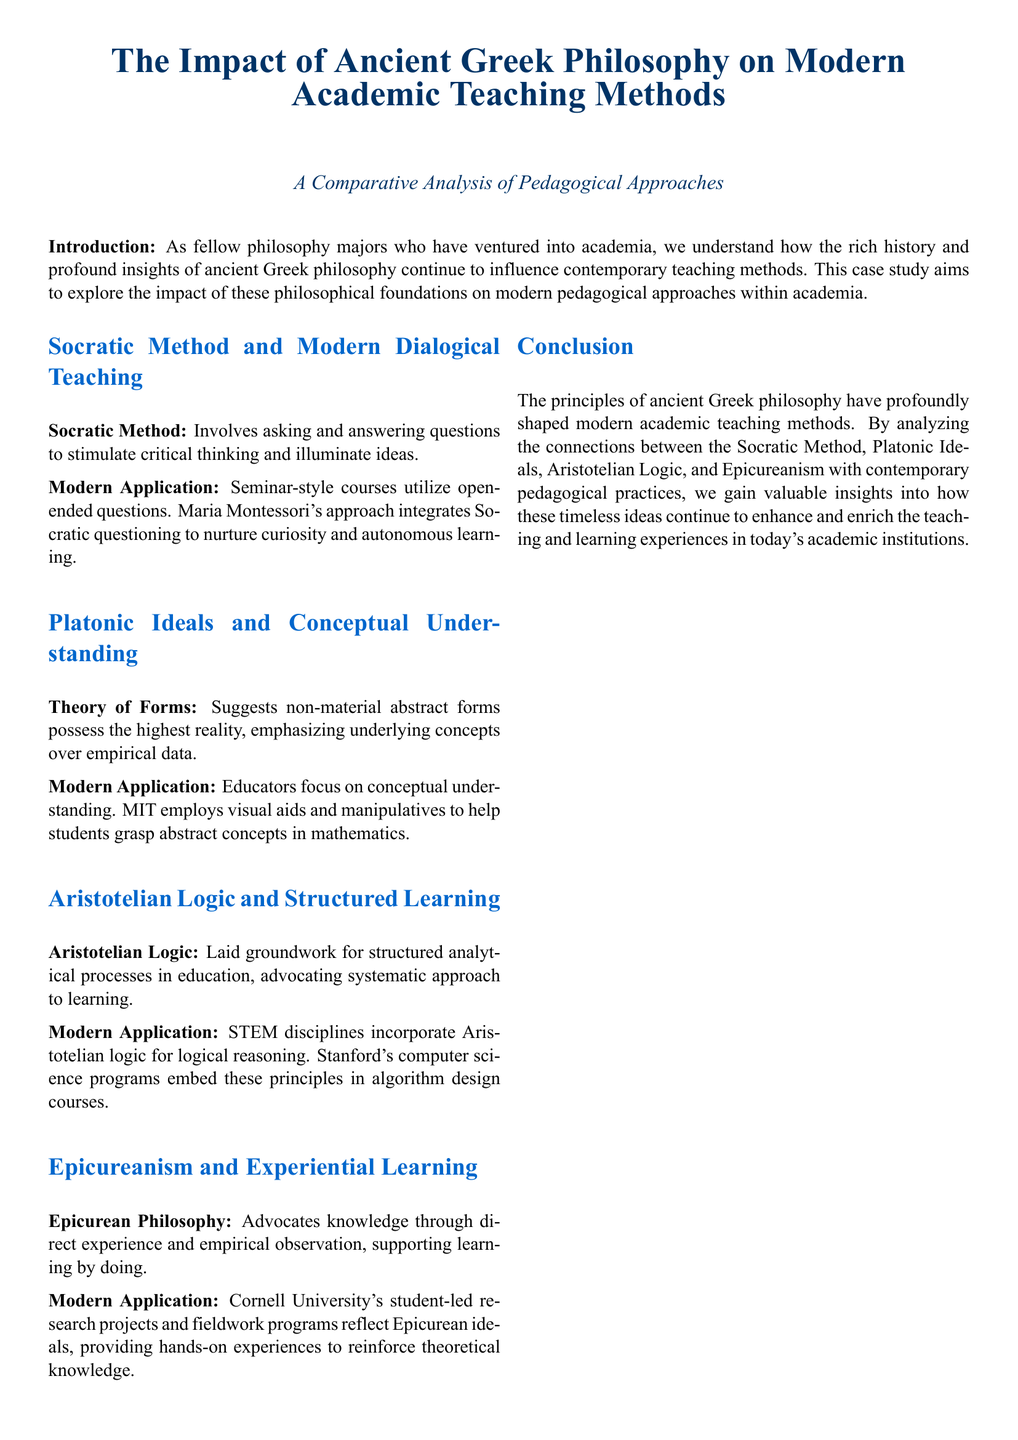What is the main focus of the case study? The case study focuses on the impact of ancient Greek philosophy on modern academic teaching methods.
Answer: The impact of ancient Greek philosophy on modern academic teaching methods Which philosophical method is linked to modern dialogical teaching? The case study mentions the Socratic Method as a historical approach influencing modern teaching.
Answer: Socratic Method What teaching method is associated with Maria Montessori? The document states that her approach integrates Socratic questioning as a key element.
Answer: Socratic questioning Which university is mentioned in relation to experiential learning? The case study references Cornell University in the context of hands-on learning experiences.
Answer: Cornell University What philosophical concept emphasizes knowledge through direct experience? The case study attributes the idea of knowledge through experience to Epicurean philosophy.
Answer: Epicureanism How does the document describe modern applications of Aristotelian logic? It highlights that STEM disciplines use Aristotelian logic in educational contexts.
Answer: STEM disciplines What does the Theory of Forms emphasize according to the document? The Theory of Forms is described as emphasizing non-material abstract forms over empirical data.
Answer: Non-material abstract forms What approach does MIT use to aid conceptual understanding? The document notes that MIT employs visual aids and manipulatives for teaching.
Answer: Visual aids and manipulatives What is the overall conclusion of the case study? The conclusion states that ancient Greek philosophy has profoundly shaped modern teaching methods.
Answer: Ancient Greek philosophy has profoundly shaped modern teaching methods 